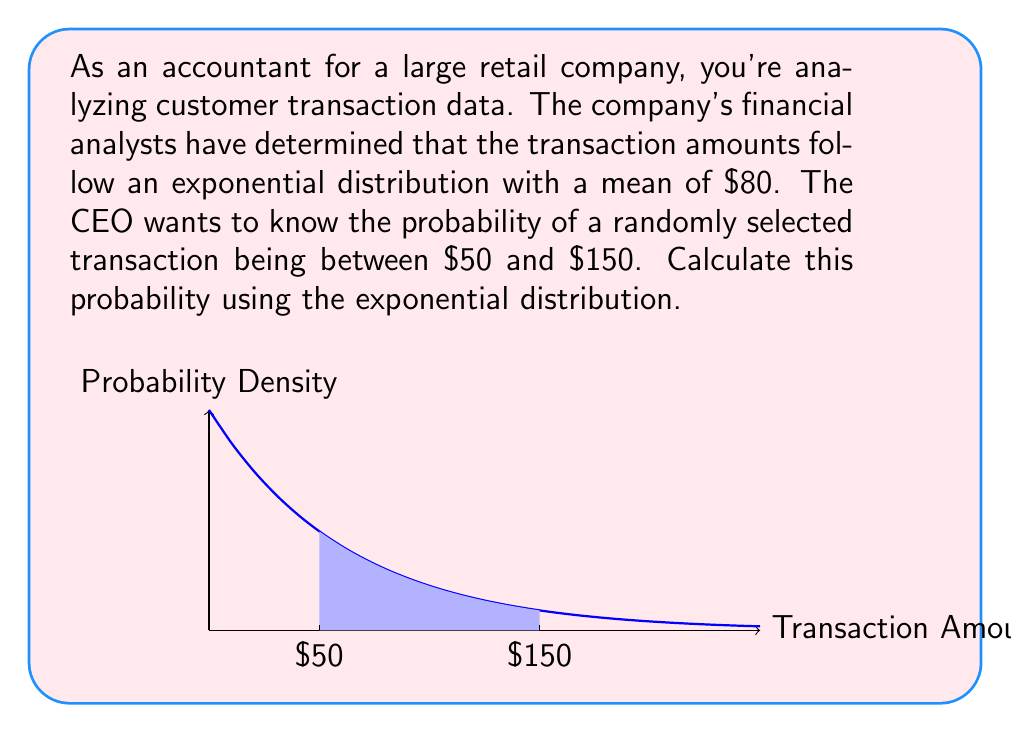Teach me how to tackle this problem. Let's approach this step-by-step:

1) The exponential distribution has a probability density function:
   $$f(x) = \lambda e^{-\lambda x}$$
   where $\lambda$ is the rate parameter.

2) We're given that the mean is $80. For the exponential distribution, the mean is $\frac{1}{\lambda}$. So:
   $$\frac{1}{\lambda} = 80$$
   $$\lambda = \frac{1}{80}$$

3) To find the probability of a transaction being between $50 and $150, we need to integrate the probability density function between these values:

   $$P(50 \leq X \leq 150) = \int_{50}^{150} \frac{1}{80}e^{-x/80} dx$$

4) We can solve this using the cumulative distribution function (CDF) of the exponential distribution:
   $$F(x) = 1 - e^{-\lambda x}$$

5) The probability is then:
   $$P(50 \leq X \leq 150) = F(150) - F(50)$$
   $$= (1 - e^{-150/80}) - (1 - e^{-50/80})$$
   $$= e^{-50/80} - e^{-150/80}$$

6) Calculating this:
   $$= e^{-0.625} - e^{-1.875}$$
   $$\approx 0.5353 - 0.1534$$
   $$\approx 0.3819$$

Therefore, the probability of a randomly selected transaction being between $50 and $150 is approximately 0.3819 or 38.19%.
Answer: 0.3819 or 38.19% 